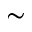<formula> <loc_0><loc_0><loc_500><loc_500>\sim</formula> 